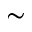<formula> <loc_0><loc_0><loc_500><loc_500>\sim</formula> 